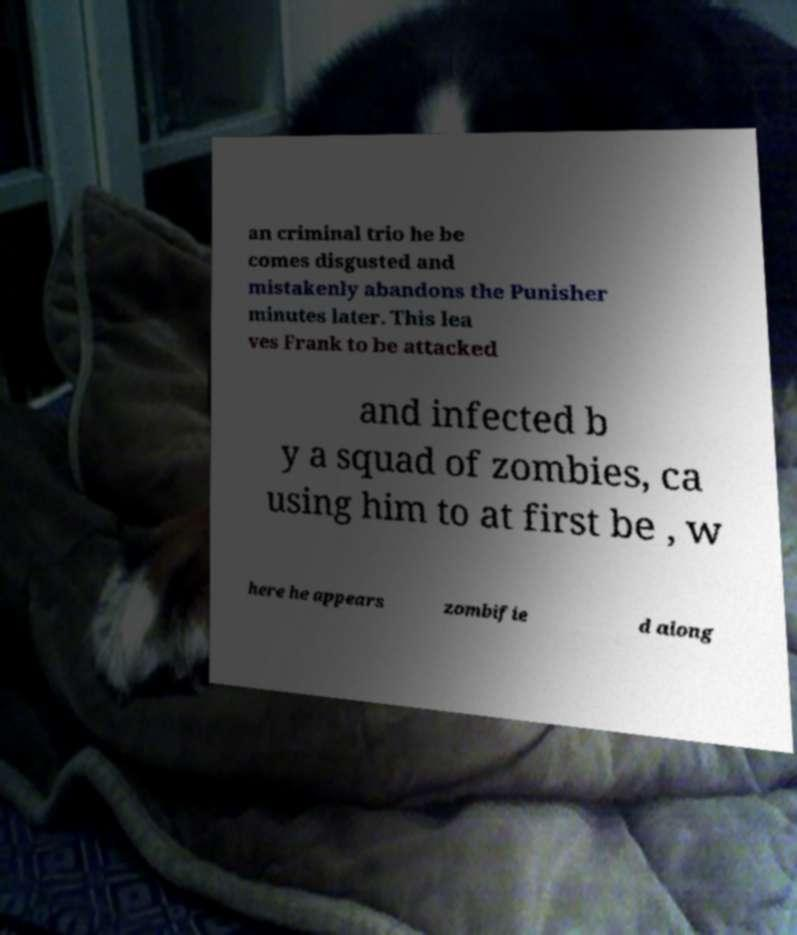Please read and relay the text visible in this image. What does it say? an criminal trio he be comes disgusted and mistakenly abandons the Punisher minutes later. This lea ves Frank to be attacked and infected b y a squad of zombies, ca using him to at first be , w here he appears zombifie d along 